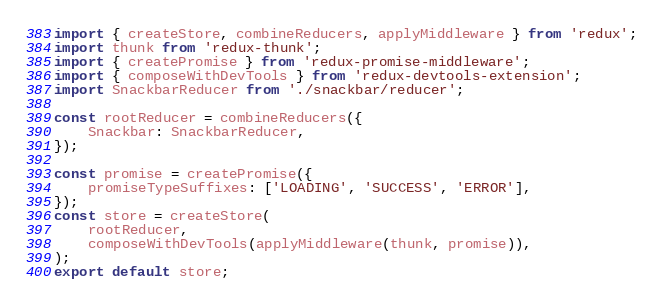Convert code to text. <code><loc_0><loc_0><loc_500><loc_500><_JavaScript_>import { createStore, combineReducers, applyMiddleware } from 'redux';
import thunk from 'redux-thunk';
import { createPromise } from 'redux-promise-middleware';
import { composeWithDevTools } from 'redux-devtools-extension';
import SnackbarReducer from './snackbar/reducer';

const rootReducer = combineReducers({
    Snackbar: SnackbarReducer,
});

const promise = createPromise({
    promiseTypeSuffixes: ['LOADING', 'SUCCESS', 'ERROR'],
});
const store = createStore(
    rootReducer,
    composeWithDevTools(applyMiddleware(thunk, promise)),
);
export default store;
</code> 